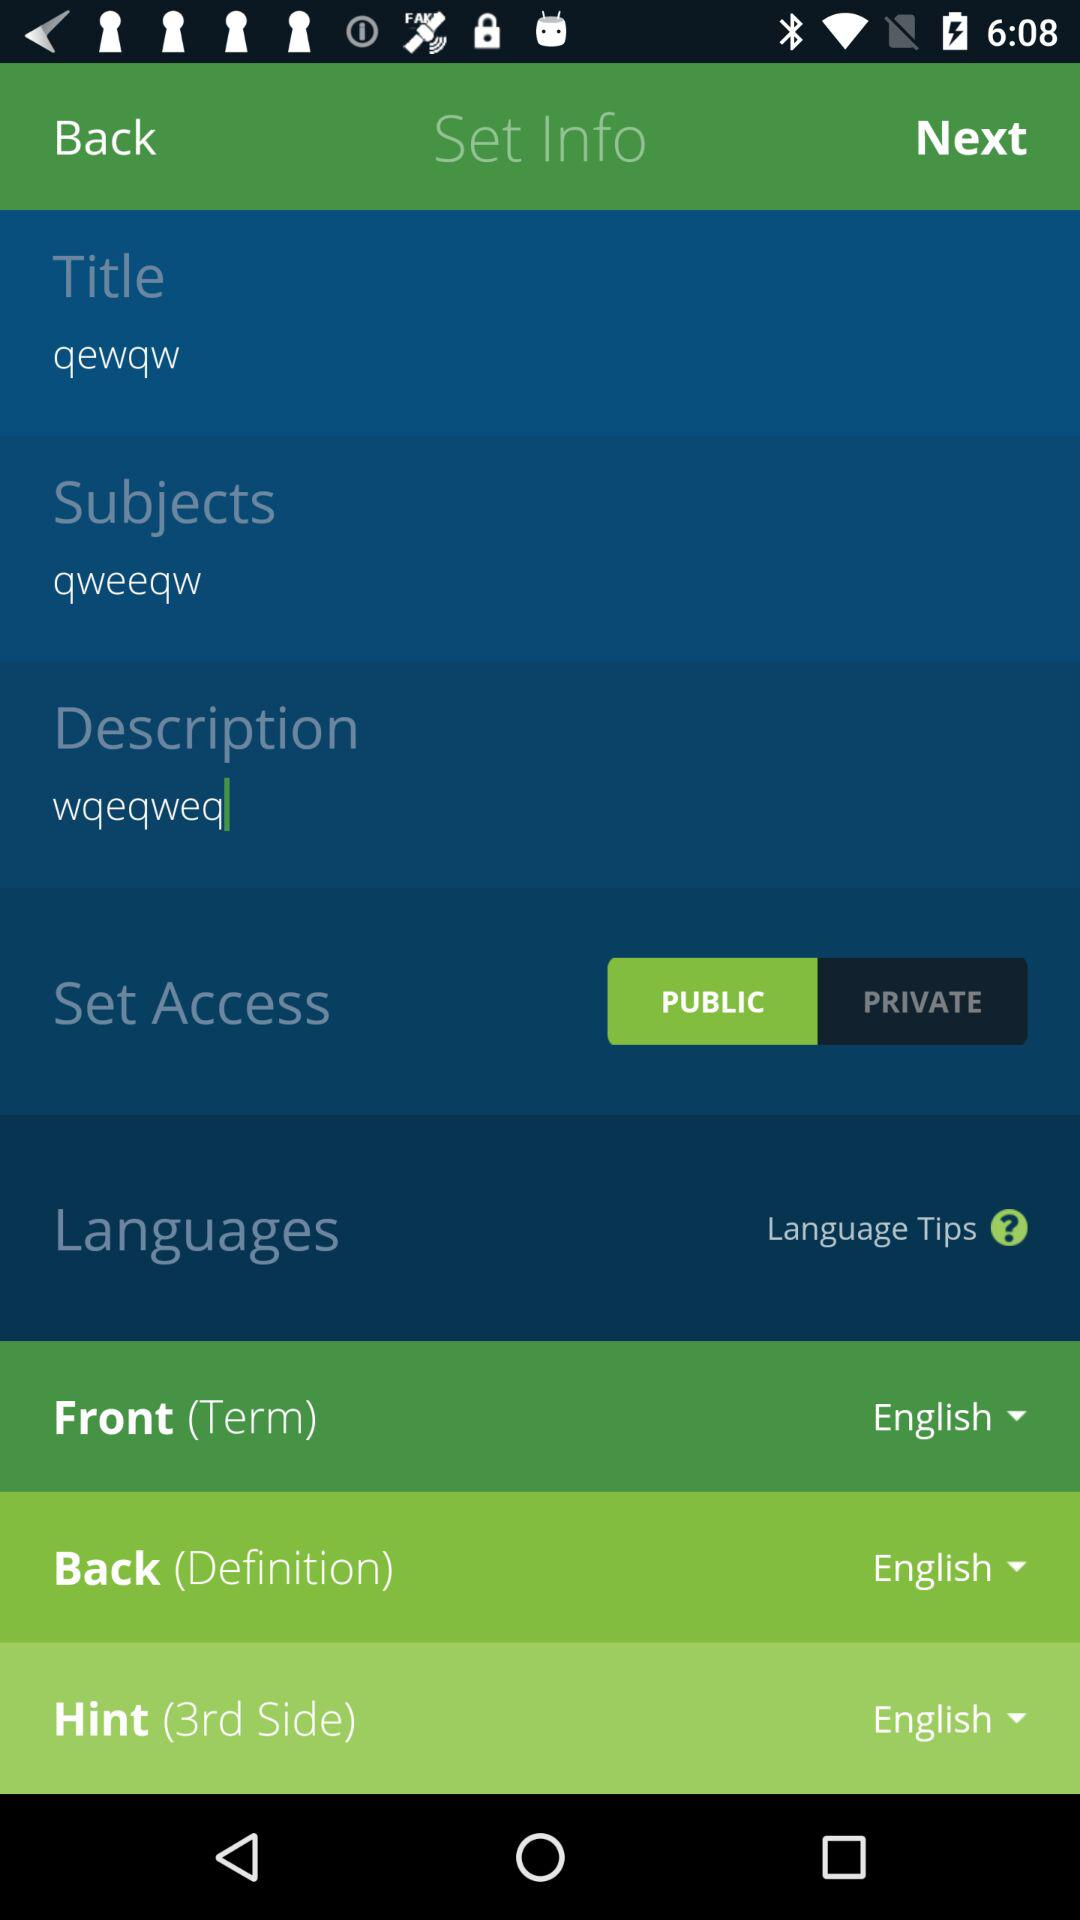What information is given under the description? The given information is "wqeqweq". 